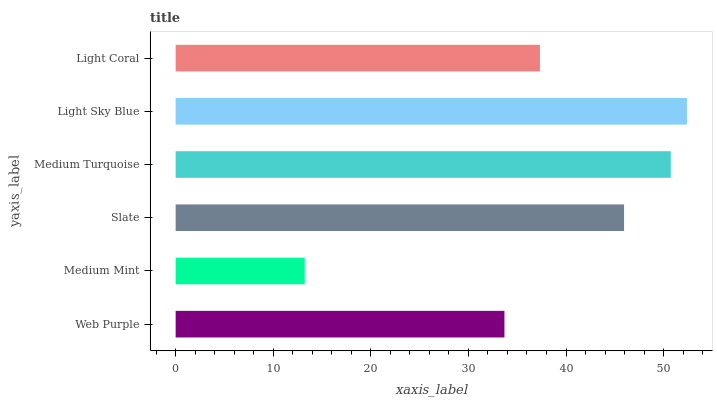Is Medium Mint the minimum?
Answer yes or no. Yes. Is Light Sky Blue the maximum?
Answer yes or no. Yes. Is Slate the minimum?
Answer yes or no. No. Is Slate the maximum?
Answer yes or no. No. Is Slate greater than Medium Mint?
Answer yes or no. Yes. Is Medium Mint less than Slate?
Answer yes or no. Yes. Is Medium Mint greater than Slate?
Answer yes or no. No. Is Slate less than Medium Mint?
Answer yes or no. No. Is Slate the high median?
Answer yes or no. Yes. Is Light Coral the low median?
Answer yes or no. Yes. Is Medium Mint the high median?
Answer yes or no. No. Is Medium Mint the low median?
Answer yes or no. No. 